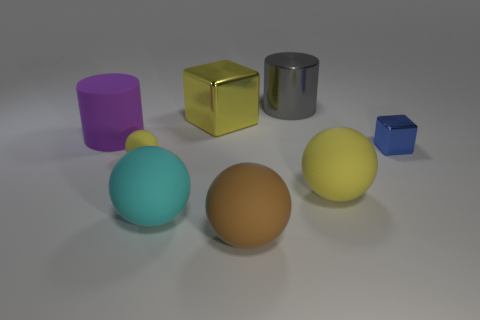There is a big thing that is both behind the large yellow matte ball and left of the large cube; what is its shape?
Your response must be concise. Cylinder. There is a purple object that is the same size as the gray metal thing; what shape is it?
Keep it short and to the point. Cylinder. The yellow shiny object has what size?
Your answer should be very brief. Large. There is a yellow sphere to the right of the sphere behind the large yellow object to the right of the big gray thing; what is its material?
Your response must be concise. Rubber. What color is the cylinder that is made of the same material as the big cyan sphere?
Provide a succinct answer. Purple. There is a large yellow object in front of the small thing to the right of the yellow shiny thing; how many yellow shiny things are left of it?
Make the answer very short. 1. There is a big sphere that is the same color as the tiny matte thing; what is it made of?
Your response must be concise. Rubber. Are there any other things that have the same shape as the purple object?
Offer a terse response. Yes. How many things are either big balls that are to the left of the gray thing or big brown rubber spheres?
Your answer should be very brief. 2. Do the big cylinder that is behind the purple rubber cylinder and the small metal object have the same color?
Ensure brevity in your answer.  No. 